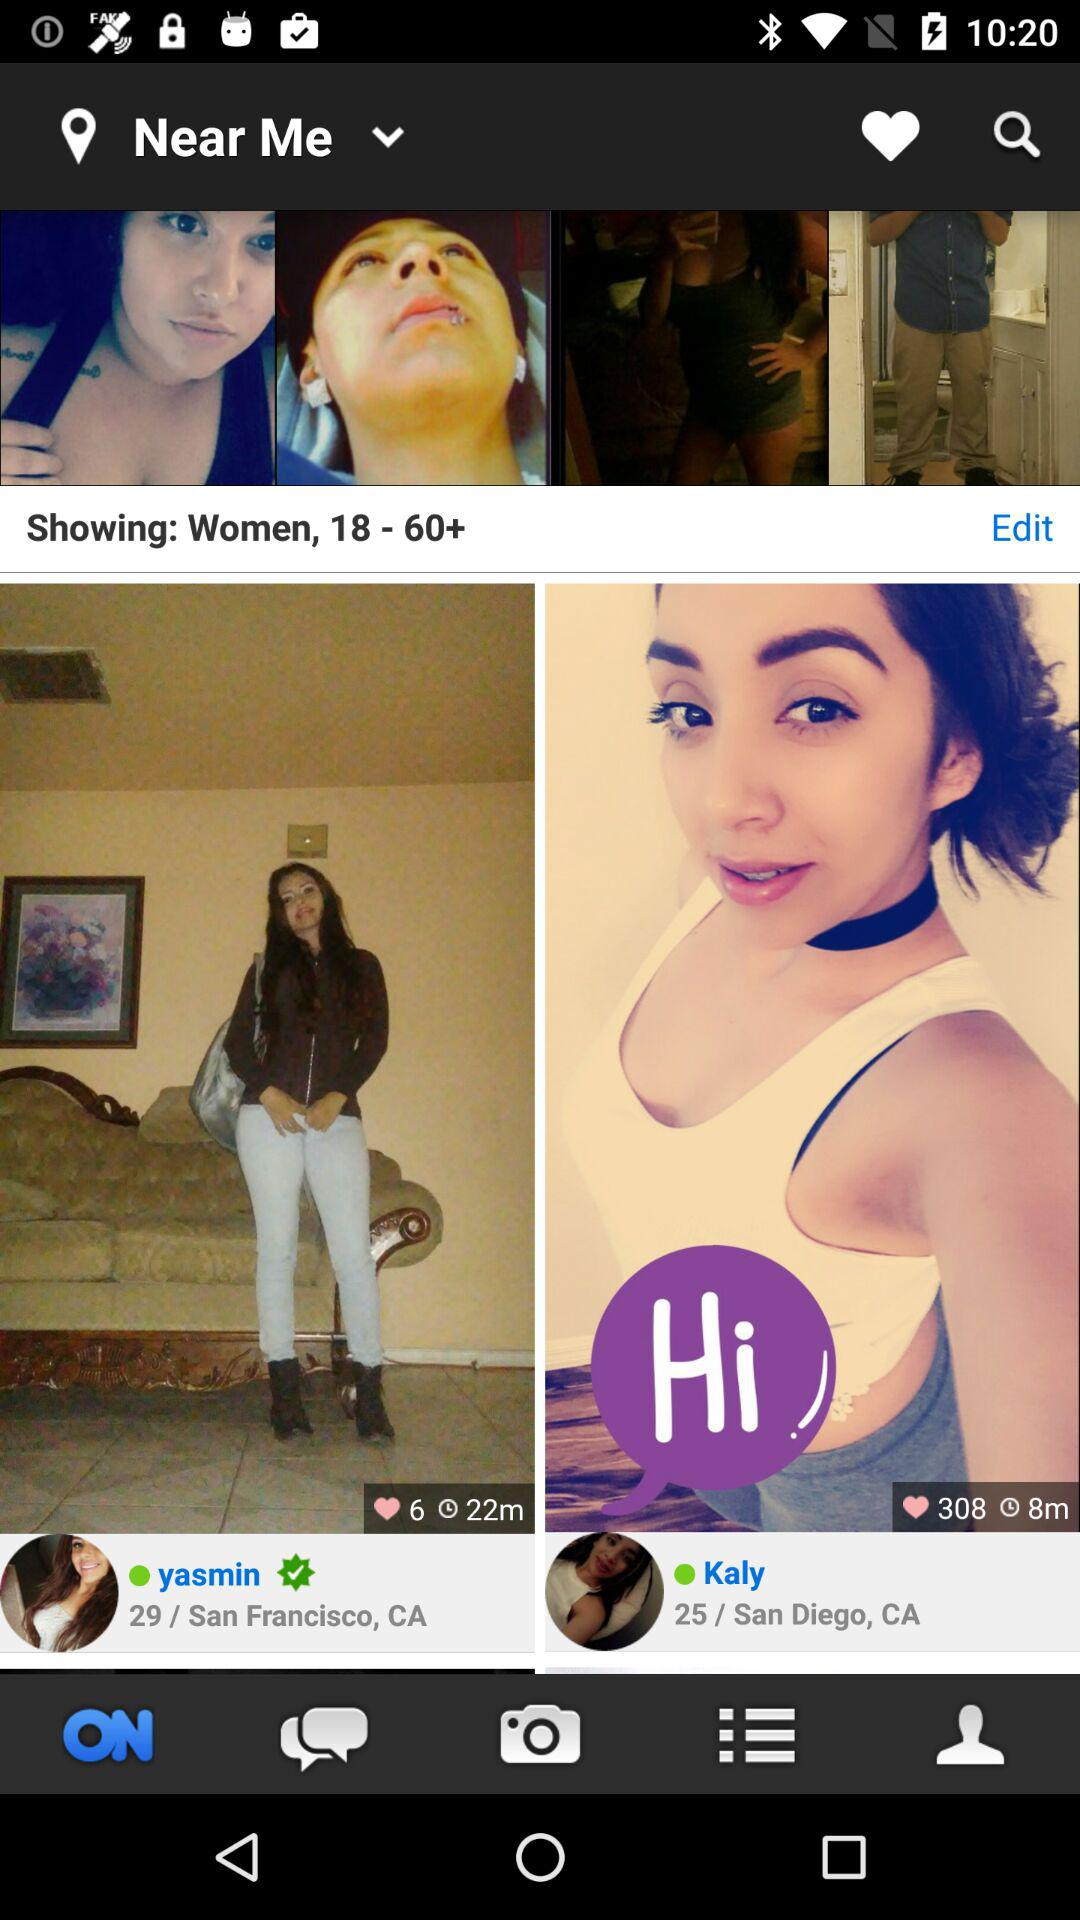What is the age of Yasmin? Yasmin is 29 years old. 